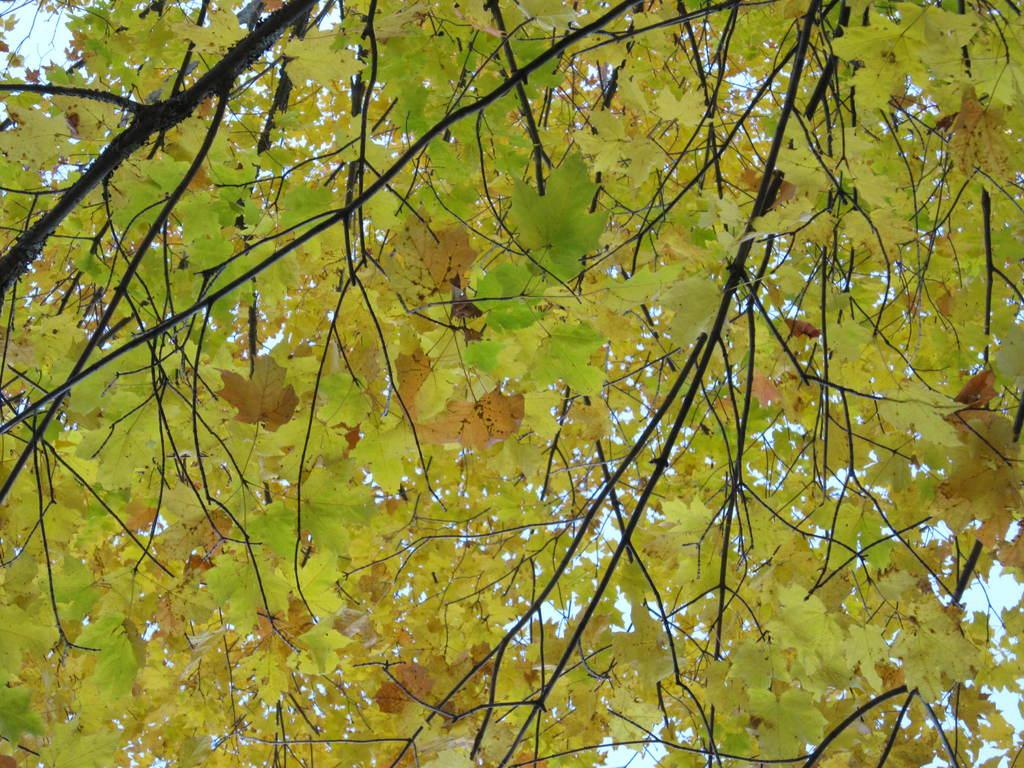Where was the picture taken? The picture was clicked outside. What can be seen in the foreground of the image? There are leaves of a tree and other objects in the foreground. What is visible in the background of the image? The sky is visible in the background. What hobbies does the squirrel in the image enjoy? There is no squirrel present in the image, so we cannot determine its hobbies. 